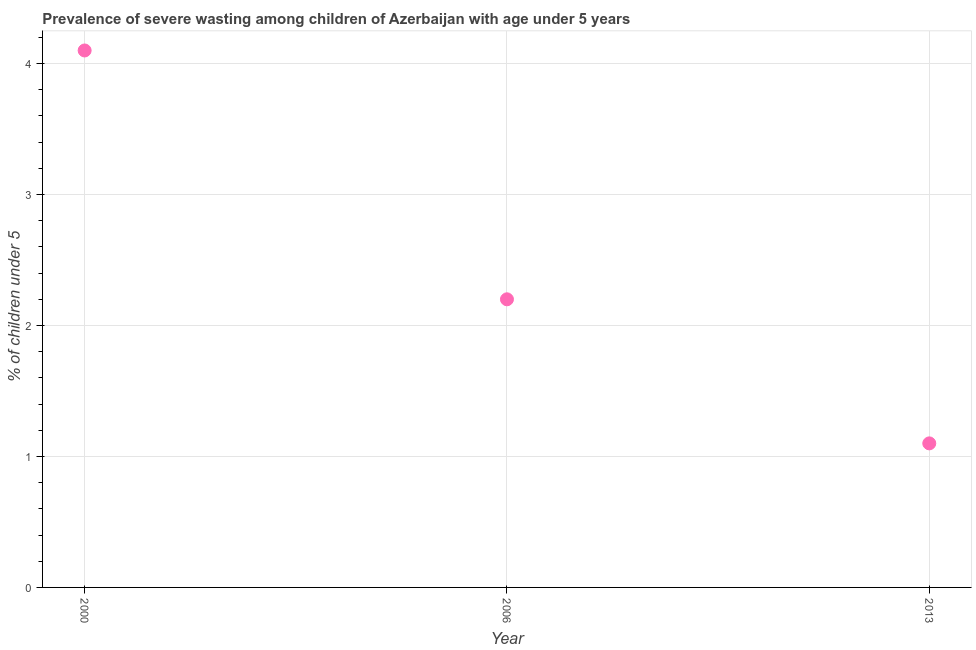What is the prevalence of severe wasting in 2013?
Your answer should be very brief. 1.1. Across all years, what is the maximum prevalence of severe wasting?
Provide a short and direct response. 4.1. Across all years, what is the minimum prevalence of severe wasting?
Provide a succinct answer. 1.1. What is the sum of the prevalence of severe wasting?
Make the answer very short. 7.4. What is the difference between the prevalence of severe wasting in 2000 and 2006?
Give a very brief answer. 1.9. What is the average prevalence of severe wasting per year?
Your answer should be compact. 2.47. What is the median prevalence of severe wasting?
Give a very brief answer. 2.2. In how many years, is the prevalence of severe wasting greater than 3.6 %?
Make the answer very short. 1. What is the ratio of the prevalence of severe wasting in 2000 to that in 2006?
Provide a short and direct response. 1.86. Is the prevalence of severe wasting in 2000 less than that in 2006?
Give a very brief answer. No. Is the difference between the prevalence of severe wasting in 2000 and 2006 greater than the difference between any two years?
Make the answer very short. No. What is the difference between the highest and the second highest prevalence of severe wasting?
Ensure brevity in your answer.  1.9. What is the difference between the highest and the lowest prevalence of severe wasting?
Your response must be concise. 3. Does the prevalence of severe wasting monotonically increase over the years?
Offer a very short reply. No. What is the title of the graph?
Your answer should be compact. Prevalence of severe wasting among children of Azerbaijan with age under 5 years. What is the label or title of the X-axis?
Your response must be concise. Year. What is the label or title of the Y-axis?
Provide a succinct answer.  % of children under 5. What is the  % of children under 5 in 2000?
Offer a very short reply. 4.1. What is the  % of children under 5 in 2006?
Your answer should be compact. 2.2. What is the  % of children under 5 in 2013?
Keep it short and to the point. 1.1. What is the difference between the  % of children under 5 in 2000 and 2006?
Make the answer very short. 1.9. What is the difference between the  % of children under 5 in 2000 and 2013?
Offer a very short reply. 3. What is the ratio of the  % of children under 5 in 2000 to that in 2006?
Offer a terse response. 1.86. What is the ratio of the  % of children under 5 in 2000 to that in 2013?
Provide a succinct answer. 3.73. 